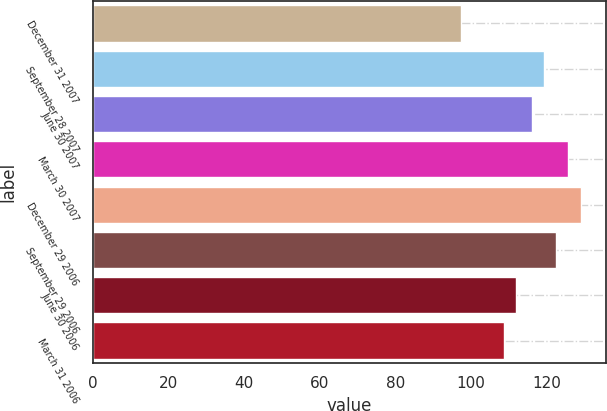Convert chart to OTSL. <chart><loc_0><loc_0><loc_500><loc_500><bar_chart><fcel>December 31 2007<fcel>September 28 2007<fcel>June 30 2007<fcel>March 30 2007<fcel>December 29 2006<fcel>September 29 2006<fcel>June 30 2006<fcel>March 31 2006<nl><fcel>97.49<fcel>119.48<fcel>116.3<fcel>125.84<fcel>129.25<fcel>122.66<fcel>111.91<fcel>108.73<nl></chart> 